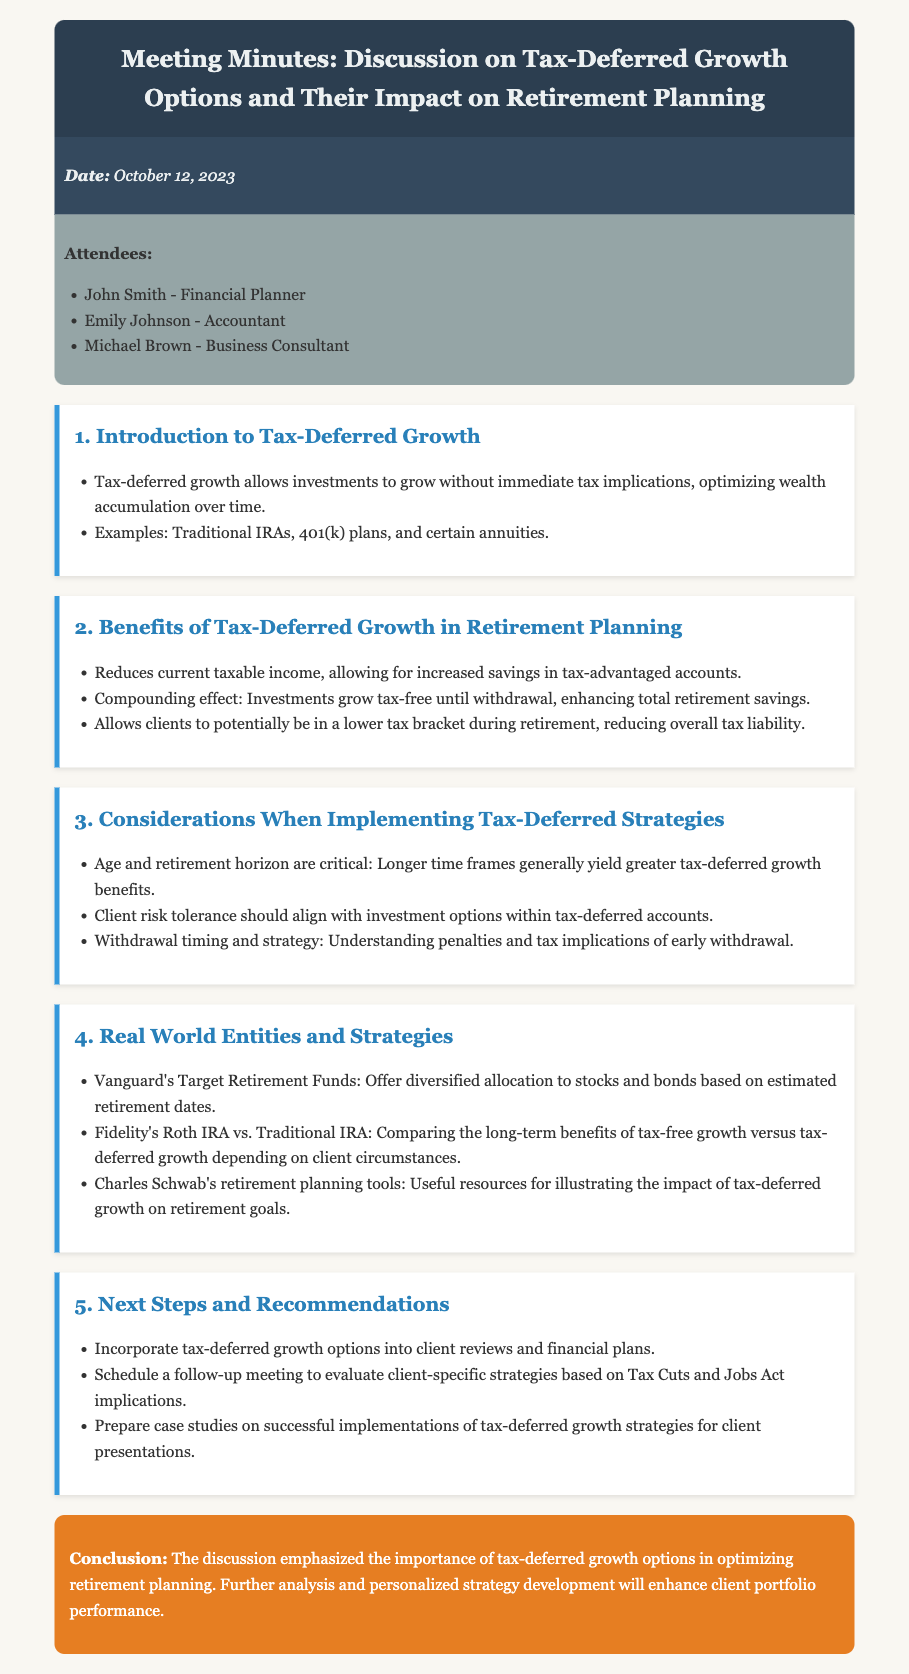What is the date of the meeting? The date of the meeting is explicitly mentioned in the document's meeting info section.
Answer: October 12, 2023 Who is the financial planner attending the meeting? The document lists the attendees, specifying who the financial planner is.
Answer: John Smith What financial products are examples of tax-deferred growth options? The introduction section provides examples of tax-deferred growth options used in retirement planning.
Answer: Traditional IRAs, 401(k) plans, and certain annuities What is one benefit of tax-deferred growth mentioned in the discussion? The benefits section outlines several advantages of tax-deferred growth in terms of retirement planning.
Answer: Reduces current taxable income What does the conclusion emphasize regarding tax-deferred growth options? The conclusion summarizes the key takeaway from the discussion on tax-deferred growth options.
Answer: Importance of tax-deferred growth options in optimizing retirement planning What will be prepared for client presentations according to the next steps? The next steps section outlines actions that will be taken post-meeting.
Answer: Case studies on successful implementations of tax-deferred growth strategies What specific tool by Charles Schwab is mentioned? The real-world entities section lists resources, including tools offered by Charles Schwab.
Answer: Charles Schwab's retirement planning tools What are clients encouraged to do in the follow-up meeting? The next steps detail what should be addressed in the follow-up meeting.
Answer: Evaluate client-specific strategies 